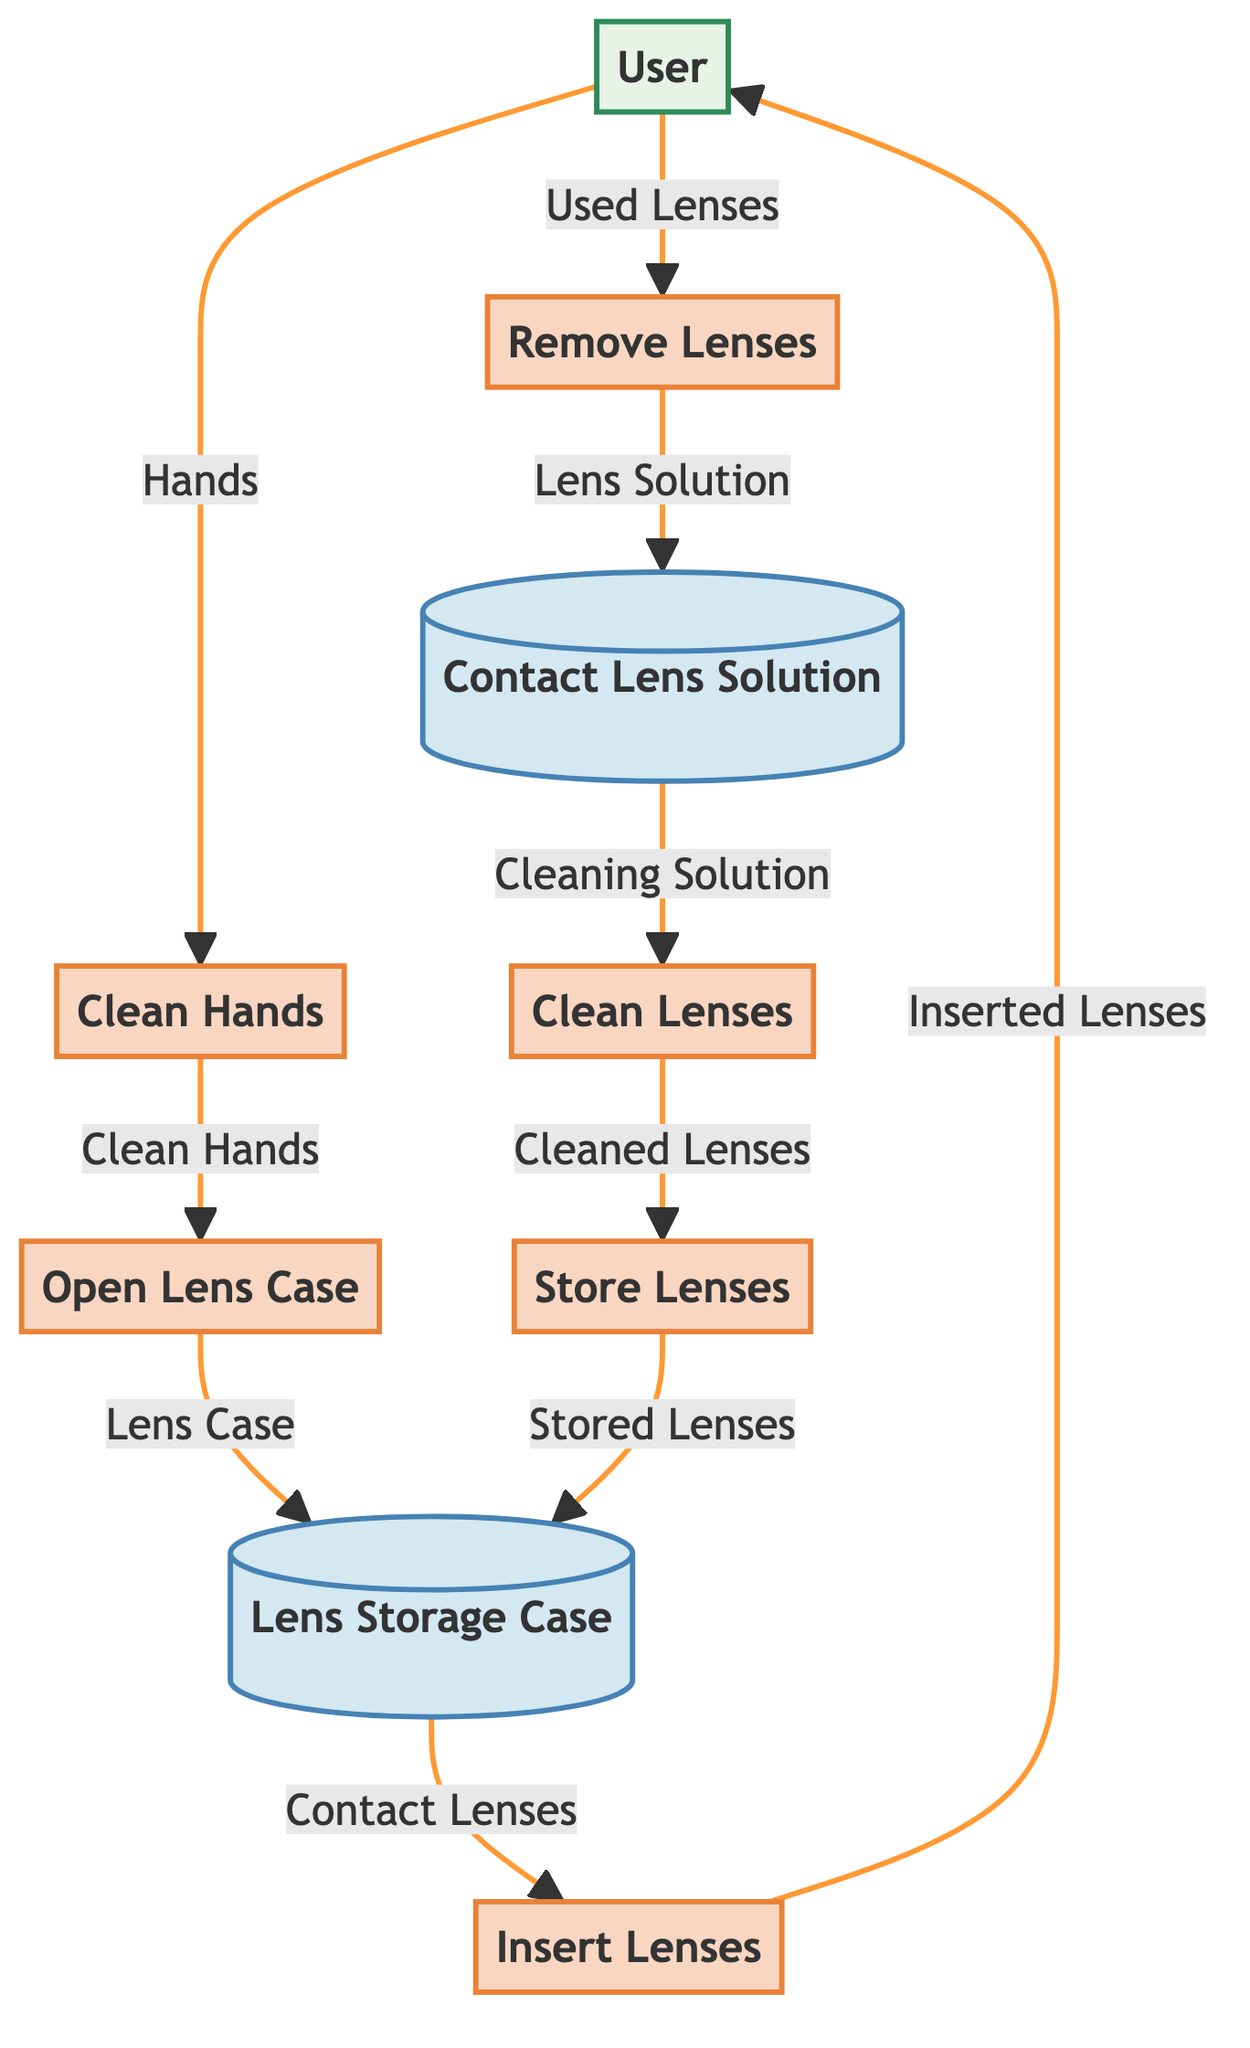What is the first process in the diagram? The first process is identified as "P1," which stands for "Clean Hands." It is the initial step in the daily routine of caring for contact lenses.
Answer: Clean Hands How many processes are shown in the diagram? The diagram lists a total of six processes (P1 to P6), relating to various stages of handling contact lenses.
Answer: 6 What does the data flow from "User" to "Clean Hands" represent? This data flow, labeled "F1," indicates that the user initiates the process by providing their hands for cleaning, which is essential before handling lenses.
Answer: Hands Which process follows after "Open Lens Case"? After "Open Lens Case," the next process is "Insert Lenses" (P3). The user retrieves the lenses to place them in their eyes.
Answer: Insert Lenses What data is transferred from "Remove Lenses" to "Contact Lens Solution"? The flow "F7" shows that the data transferred from "Remove Lenses" to "Contact Lens Solution" represents the used lenses, which are sent for cleaning.
Answer: Lens Solution How does "Clean Lenses" relate to "Store Lenses"? The "Clean Lenses" process (P5) produces "Cleaned Lenses," which are then input into the "Store Lenses" process (P6) to be placed in the storage case.
Answer: Cleaned Lenses Which data store contains stored lenses? The data store that contains stored lenses is labeled "D1," referred to as "Lens Storage Case." It is used to keep lenses when they are not in use.
Answer: Lens Storage Case How many data flows are present in the diagram? There are a total of ten data flows (F1 to F10) that connect various processes and data stores within the contact lens routine.
Answer: 10 What is the role of "Contact Lens Solution" in the diagram? "Contact Lens Solution" (D2) acts as a cleaning agent that is necessary for the "Clean Lenses" process, indicating its importance in maintaining lens hygiene.
Answer: Cleaning Solution 